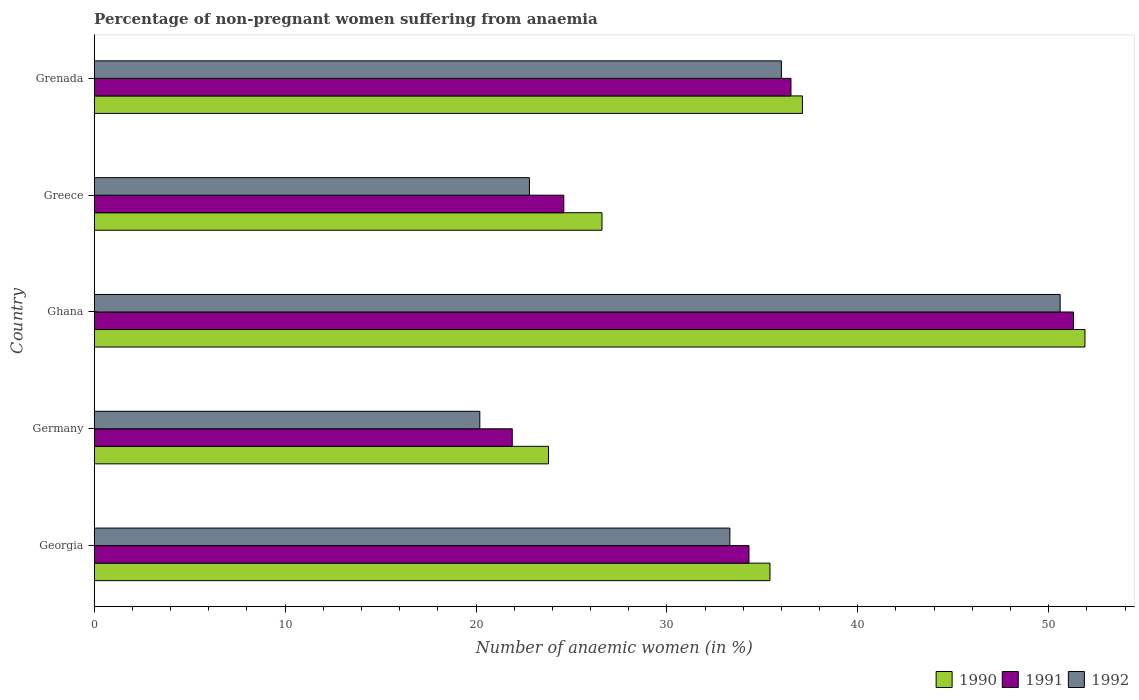Are the number of bars per tick equal to the number of legend labels?
Give a very brief answer. Yes. Are the number of bars on each tick of the Y-axis equal?
Keep it short and to the point. Yes. How many bars are there on the 3rd tick from the top?
Offer a very short reply. 3. How many bars are there on the 4th tick from the bottom?
Provide a short and direct response. 3. In how many cases, is the number of bars for a given country not equal to the number of legend labels?
Your response must be concise. 0. What is the percentage of non-pregnant women suffering from anaemia in 1990 in Greece?
Provide a short and direct response. 26.6. Across all countries, what is the maximum percentage of non-pregnant women suffering from anaemia in 1991?
Make the answer very short. 51.3. Across all countries, what is the minimum percentage of non-pregnant women suffering from anaemia in 1991?
Your answer should be compact. 21.9. In which country was the percentage of non-pregnant women suffering from anaemia in 1990 maximum?
Ensure brevity in your answer.  Ghana. In which country was the percentage of non-pregnant women suffering from anaemia in 1991 minimum?
Provide a succinct answer. Germany. What is the total percentage of non-pregnant women suffering from anaemia in 1990 in the graph?
Give a very brief answer. 174.8. What is the difference between the percentage of non-pregnant women suffering from anaemia in 1990 in Ghana and that in Greece?
Keep it short and to the point. 25.3. What is the difference between the percentage of non-pregnant women suffering from anaemia in 1990 in Greece and the percentage of non-pregnant women suffering from anaemia in 1992 in Georgia?
Provide a succinct answer. -6.7. What is the average percentage of non-pregnant women suffering from anaemia in 1990 per country?
Keep it short and to the point. 34.96. What is the difference between the percentage of non-pregnant women suffering from anaemia in 1992 and percentage of non-pregnant women suffering from anaemia in 1990 in Germany?
Your response must be concise. -3.6. In how many countries, is the percentage of non-pregnant women suffering from anaemia in 1990 greater than 48 %?
Offer a very short reply. 1. What is the ratio of the percentage of non-pregnant women suffering from anaemia in 1992 in Germany to that in Greece?
Keep it short and to the point. 0.89. Is the percentage of non-pregnant women suffering from anaemia in 1991 in Georgia less than that in Germany?
Make the answer very short. No. What is the difference between the highest and the second highest percentage of non-pregnant women suffering from anaemia in 1991?
Give a very brief answer. 14.8. What is the difference between the highest and the lowest percentage of non-pregnant women suffering from anaemia in 1990?
Ensure brevity in your answer.  28.1. Is the sum of the percentage of non-pregnant women suffering from anaemia in 1990 in Greece and Grenada greater than the maximum percentage of non-pregnant women suffering from anaemia in 1991 across all countries?
Your answer should be compact. Yes. What does the 2nd bar from the top in Ghana represents?
Keep it short and to the point. 1991. What does the 2nd bar from the bottom in Greece represents?
Your response must be concise. 1991. Is it the case that in every country, the sum of the percentage of non-pregnant women suffering from anaemia in 1991 and percentage of non-pregnant women suffering from anaemia in 1990 is greater than the percentage of non-pregnant women suffering from anaemia in 1992?
Make the answer very short. Yes. How many countries are there in the graph?
Provide a succinct answer. 5. Are the values on the major ticks of X-axis written in scientific E-notation?
Make the answer very short. No. Where does the legend appear in the graph?
Provide a short and direct response. Bottom right. How many legend labels are there?
Your response must be concise. 3. What is the title of the graph?
Make the answer very short. Percentage of non-pregnant women suffering from anaemia. Does "2004" appear as one of the legend labels in the graph?
Offer a very short reply. No. What is the label or title of the X-axis?
Offer a terse response. Number of anaemic women (in %). What is the label or title of the Y-axis?
Provide a short and direct response. Country. What is the Number of anaemic women (in %) of 1990 in Georgia?
Give a very brief answer. 35.4. What is the Number of anaemic women (in %) in 1991 in Georgia?
Keep it short and to the point. 34.3. What is the Number of anaemic women (in %) of 1992 in Georgia?
Ensure brevity in your answer.  33.3. What is the Number of anaemic women (in %) of 1990 in Germany?
Provide a short and direct response. 23.8. What is the Number of anaemic women (in %) in 1991 in Germany?
Your answer should be very brief. 21.9. What is the Number of anaemic women (in %) in 1992 in Germany?
Keep it short and to the point. 20.2. What is the Number of anaemic women (in %) in 1990 in Ghana?
Ensure brevity in your answer.  51.9. What is the Number of anaemic women (in %) of 1991 in Ghana?
Provide a succinct answer. 51.3. What is the Number of anaemic women (in %) in 1992 in Ghana?
Offer a very short reply. 50.6. What is the Number of anaemic women (in %) in 1990 in Greece?
Provide a short and direct response. 26.6. What is the Number of anaemic women (in %) in 1991 in Greece?
Your answer should be compact. 24.6. What is the Number of anaemic women (in %) in 1992 in Greece?
Your answer should be compact. 22.8. What is the Number of anaemic women (in %) in 1990 in Grenada?
Ensure brevity in your answer.  37.1. What is the Number of anaemic women (in %) of 1991 in Grenada?
Your answer should be compact. 36.5. Across all countries, what is the maximum Number of anaemic women (in %) of 1990?
Offer a terse response. 51.9. Across all countries, what is the maximum Number of anaemic women (in %) of 1991?
Give a very brief answer. 51.3. Across all countries, what is the maximum Number of anaemic women (in %) in 1992?
Provide a succinct answer. 50.6. Across all countries, what is the minimum Number of anaemic women (in %) in 1990?
Offer a very short reply. 23.8. Across all countries, what is the minimum Number of anaemic women (in %) of 1991?
Provide a short and direct response. 21.9. Across all countries, what is the minimum Number of anaemic women (in %) in 1992?
Offer a very short reply. 20.2. What is the total Number of anaemic women (in %) in 1990 in the graph?
Provide a succinct answer. 174.8. What is the total Number of anaemic women (in %) in 1991 in the graph?
Ensure brevity in your answer.  168.6. What is the total Number of anaemic women (in %) in 1992 in the graph?
Offer a very short reply. 162.9. What is the difference between the Number of anaemic women (in %) of 1990 in Georgia and that in Ghana?
Your answer should be compact. -16.5. What is the difference between the Number of anaemic women (in %) in 1991 in Georgia and that in Ghana?
Your answer should be compact. -17. What is the difference between the Number of anaemic women (in %) of 1992 in Georgia and that in Ghana?
Your answer should be very brief. -17.3. What is the difference between the Number of anaemic women (in %) of 1990 in Georgia and that in Greece?
Keep it short and to the point. 8.8. What is the difference between the Number of anaemic women (in %) of 1991 in Georgia and that in Greece?
Give a very brief answer. 9.7. What is the difference between the Number of anaemic women (in %) in 1992 in Georgia and that in Greece?
Keep it short and to the point. 10.5. What is the difference between the Number of anaemic women (in %) of 1990 in Georgia and that in Grenada?
Your answer should be compact. -1.7. What is the difference between the Number of anaemic women (in %) in 1991 in Georgia and that in Grenada?
Make the answer very short. -2.2. What is the difference between the Number of anaemic women (in %) of 1992 in Georgia and that in Grenada?
Ensure brevity in your answer.  -2.7. What is the difference between the Number of anaemic women (in %) in 1990 in Germany and that in Ghana?
Your response must be concise. -28.1. What is the difference between the Number of anaemic women (in %) of 1991 in Germany and that in Ghana?
Ensure brevity in your answer.  -29.4. What is the difference between the Number of anaemic women (in %) of 1992 in Germany and that in Ghana?
Make the answer very short. -30.4. What is the difference between the Number of anaemic women (in %) of 1990 in Germany and that in Greece?
Your answer should be compact. -2.8. What is the difference between the Number of anaemic women (in %) of 1991 in Germany and that in Grenada?
Make the answer very short. -14.6. What is the difference between the Number of anaemic women (in %) of 1992 in Germany and that in Grenada?
Give a very brief answer. -15.8. What is the difference between the Number of anaemic women (in %) in 1990 in Ghana and that in Greece?
Offer a very short reply. 25.3. What is the difference between the Number of anaemic women (in %) in 1991 in Ghana and that in Greece?
Provide a short and direct response. 26.7. What is the difference between the Number of anaemic women (in %) of 1992 in Ghana and that in Greece?
Offer a terse response. 27.8. What is the difference between the Number of anaemic women (in %) in 1991 in Ghana and that in Grenada?
Your answer should be compact. 14.8. What is the difference between the Number of anaemic women (in %) of 1992 in Greece and that in Grenada?
Give a very brief answer. -13.2. What is the difference between the Number of anaemic women (in %) in 1990 in Georgia and the Number of anaemic women (in %) in 1991 in Germany?
Offer a terse response. 13.5. What is the difference between the Number of anaemic women (in %) of 1991 in Georgia and the Number of anaemic women (in %) of 1992 in Germany?
Your answer should be compact. 14.1. What is the difference between the Number of anaemic women (in %) of 1990 in Georgia and the Number of anaemic women (in %) of 1991 in Ghana?
Keep it short and to the point. -15.9. What is the difference between the Number of anaemic women (in %) in 1990 in Georgia and the Number of anaemic women (in %) in 1992 in Ghana?
Offer a very short reply. -15.2. What is the difference between the Number of anaemic women (in %) in 1991 in Georgia and the Number of anaemic women (in %) in 1992 in Ghana?
Offer a terse response. -16.3. What is the difference between the Number of anaemic women (in %) in 1990 in Georgia and the Number of anaemic women (in %) in 1992 in Greece?
Your response must be concise. 12.6. What is the difference between the Number of anaemic women (in %) of 1990 in Germany and the Number of anaemic women (in %) of 1991 in Ghana?
Ensure brevity in your answer.  -27.5. What is the difference between the Number of anaemic women (in %) in 1990 in Germany and the Number of anaemic women (in %) in 1992 in Ghana?
Your answer should be compact. -26.8. What is the difference between the Number of anaemic women (in %) of 1991 in Germany and the Number of anaemic women (in %) of 1992 in Ghana?
Your response must be concise. -28.7. What is the difference between the Number of anaemic women (in %) of 1990 in Germany and the Number of anaemic women (in %) of 1992 in Greece?
Offer a very short reply. 1. What is the difference between the Number of anaemic women (in %) of 1990 in Germany and the Number of anaemic women (in %) of 1992 in Grenada?
Make the answer very short. -12.2. What is the difference between the Number of anaemic women (in %) of 1991 in Germany and the Number of anaemic women (in %) of 1992 in Grenada?
Offer a terse response. -14.1. What is the difference between the Number of anaemic women (in %) in 1990 in Ghana and the Number of anaemic women (in %) in 1991 in Greece?
Make the answer very short. 27.3. What is the difference between the Number of anaemic women (in %) in 1990 in Ghana and the Number of anaemic women (in %) in 1992 in Greece?
Your response must be concise. 29.1. What is the difference between the Number of anaemic women (in %) of 1990 in Greece and the Number of anaemic women (in %) of 1992 in Grenada?
Give a very brief answer. -9.4. What is the difference between the Number of anaemic women (in %) of 1991 in Greece and the Number of anaemic women (in %) of 1992 in Grenada?
Your response must be concise. -11.4. What is the average Number of anaemic women (in %) of 1990 per country?
Offer a terse response. 34.96. What is the average Number of anaemic women (in %) of 1991 per country?
Give a very brief answer. 33.72. What is the average Number of anaemic women (in %) in 1992 per country?
Ensure brevity in your answer.  32.58. What is the difference between the Number of anaemic women (in %) in 1990 and Number of anaemic women (in %) in 1992 in Georgia?
Your answer should be very brief. 2.1. What is the difference between the Number of anaemic women (in %) in 1991 and Number of anaemic women (in %) in 1992 in Georgia?
Provide a short and direct response. 1. What is the difference between the Number of anaemic women (in %) in 1991 and Number of anaemic women (in %) in 1992 in Germany?
Offer a terse response. 1.7. What is the difference between the Number of anaemic women (in %) in 1990 and Number of anaemic women (in %) in 1991 in Ghana?
Provide a short and direct response. 0.6. What is the difference between the Number of anaemic women (in %) in 1990 and Number of anaemic women (in %) in 1992 in Greece?
Give a very brief answer. 3.8. What is the difference between the Number of anaemic women (in %) of 1991 and Number of anaemic women (in %) of 1992 in Greece?
Provide a short and direct response. 1.8. What is the difference between the Number of anaemic women (in %) of 1991 and Number of anaemic women (in %) of 1992 in Grenada?
Ensure brevity in your answer.  0.5. What is the ratio of the Number of anaemic women (in %) in 1990 in Georgia to that in Germany?
Ensure brevity in your answer.  1.49. What is the ratio of the Number of anaemic women (in %) in 1991 in Georgia to that in Germany?
Ensure brevity in your answer.  1.57. What is the ratio of the Number of anaemic women (in %) in 1992 in Georgia to that in Germany?
Provide a succinct answer. 1.65. What is the ratio of the Number of anaemic women (in %) in 1990 in Georgia to that in Ghana?
Your response must be concise. 0.68. What is the ratio of the Number of anaemic women (in %) of 1991 in Georgia to that in Ghana?
Your response must be concise. 0.67. What is the ratio of the Number of anaemic women (in %) of 1992 in Georgia to that in Ghana?
Ensure brevity in your answer.  0.66. What is the ratio of the Number of anaemic women (in %) of 1990 in Georgia to that in Greece?
Keep it short and to the point. 1.33. What is the ratio of the Number of anaemic women (in %) in 1991 in Georgia to that in Greece?
Provide a succinct answer. 1.39. What is the ratio of the Number of anaemic women (in %) in 1992 in Georgia to that in Greece?
Offer a very short reply. 1.46. What is the ratio of the Number of anaemic women (in %) of 1990 in Georgia to that in Grenada?
Make the answer very short. 0.95. What is the ratio of the Number of anaemic women (in %) of 1991 in Georgia to that in Grenada?
Offer a terse response. 0.94. What is the ratio of the Number of anaemic women (in %) of 1992 in Georgia to that in Grenada?
Make the answer very short. 0.93. What is the ratio of the Number of anaemic women (in %) of 1990 in Germany to that in Ghana?
Give a very brief answer. 0.46. What is the ratio of the Number of anaemic women (in %) of 1991 in Germany to that in Ghana?
Ensure brevity in your answer.  0.43. What is the ratio of the Number of anaemic women (in %) of 1992 in Germany to that in Ghana?
Your answer should be compact. 0.4. What is the ratio of the Number of anaemic women (in %) in 1990 in Germany to that in Greece?
Your answer should be compact. 0.89. What is the ratio of the Number of anaemic women (in %) of 1991 in Germany to that in Greece?
Provide a short and direct response. 0.89. What is the ratio of the Number of anaemic women (in %) of 1992 in Germany to that in Greece?
Your answer should be compact. 0.89. What is the ratio of the Number of anaemic women (in %) in 1990 in Germany to that in Grenada?
Give a very brief answer. 0.64. What is the ratio of the Number of anaemic women (in %) in 1991 in Germany to that in Grenada?
Keep it short and to the point. 0.6. What is the ratio of the Number of anaemic women (in %) in 1992 in Germany to that in Grenada?
Your response must be concise. 0.56. What is the ratio of the Number of anaemic women (in %) in 1990 in Ghana to that in Greece?
Ensure brevity in your answer.  1.95. What is the ratio of the Number of anaemic women (in %) in 1991 in Ghana to that in Greece?
Provide a short and direct response. 2.09. What is the ratio of the Number of anaemic women (in %) in 1992 in Ghana to that in Greece?
Your answer should be compact. 2.22. What is the ratio of the Number of anaemic women (in %) in 1990 in Ghana to that in Grenada?
Your answer should be compact. 1.4. What is the ratio of the Number of anaemic women (in %) of 1991 in Ghana to that in Grenada?
Your answer should be compact. 1.41. What is the ratio of the Number of anaemic women (in %) in 1992 in Ghana to that in Grenada?
Ensure brevity in your answer.  1.41. What is the ratio of the Number of anaemic women (in %) in 1990 in Greece to that in Grenada?
Ensure brevity in your answer.  0.72. What is the ratio of the Number of anaemic women (in %) in 1991 in Greece to that in Grenada?
Your answer should be very brief. 0.67. What is the ratio of the Number of anaemic women (in %) of 1992 in Greece to that in Grenada?
Offer a very short reply. 0.63. What is the difference between the highest and the second highest Number of anaemic women (in %) of 1990?
Offer a terse response. 14.8. What is the difference between the highest and the second highest Number of anaemic women (in %) of 1991?
Your answer should be very brief. 14.8. What is the difference between the highest and the lowest Number of anaemic women (in %) in 1990?
Give a very brief answer. 28.1. What is the difference between the highest and the lowest Number of anaemic women (in %) of 1991?
Make the answer very short. 29.4. What is the difference between the highest and the lowest Number of anaemic women (in %) in 1992?
Your response must be concise. 30.4. 